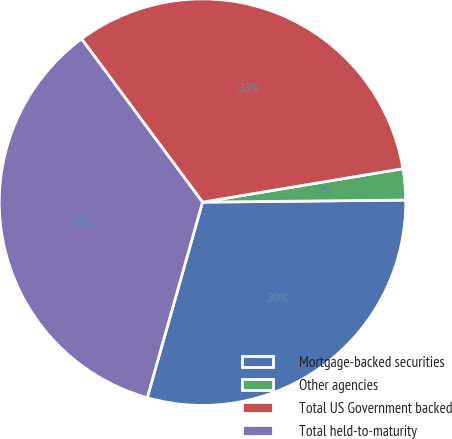<chart> <loc_0><loc_0><loc_500><loc_500><pie_chart><fcel>Mortgage-backed securities<fcel>Other agencies<fcel>Total US Government backed<fcel>Total held-to-maturity<nl><fcel>29.55%<fcel>2.47%<fcel>32.51%<fcel>35.47%<nl></chart> 